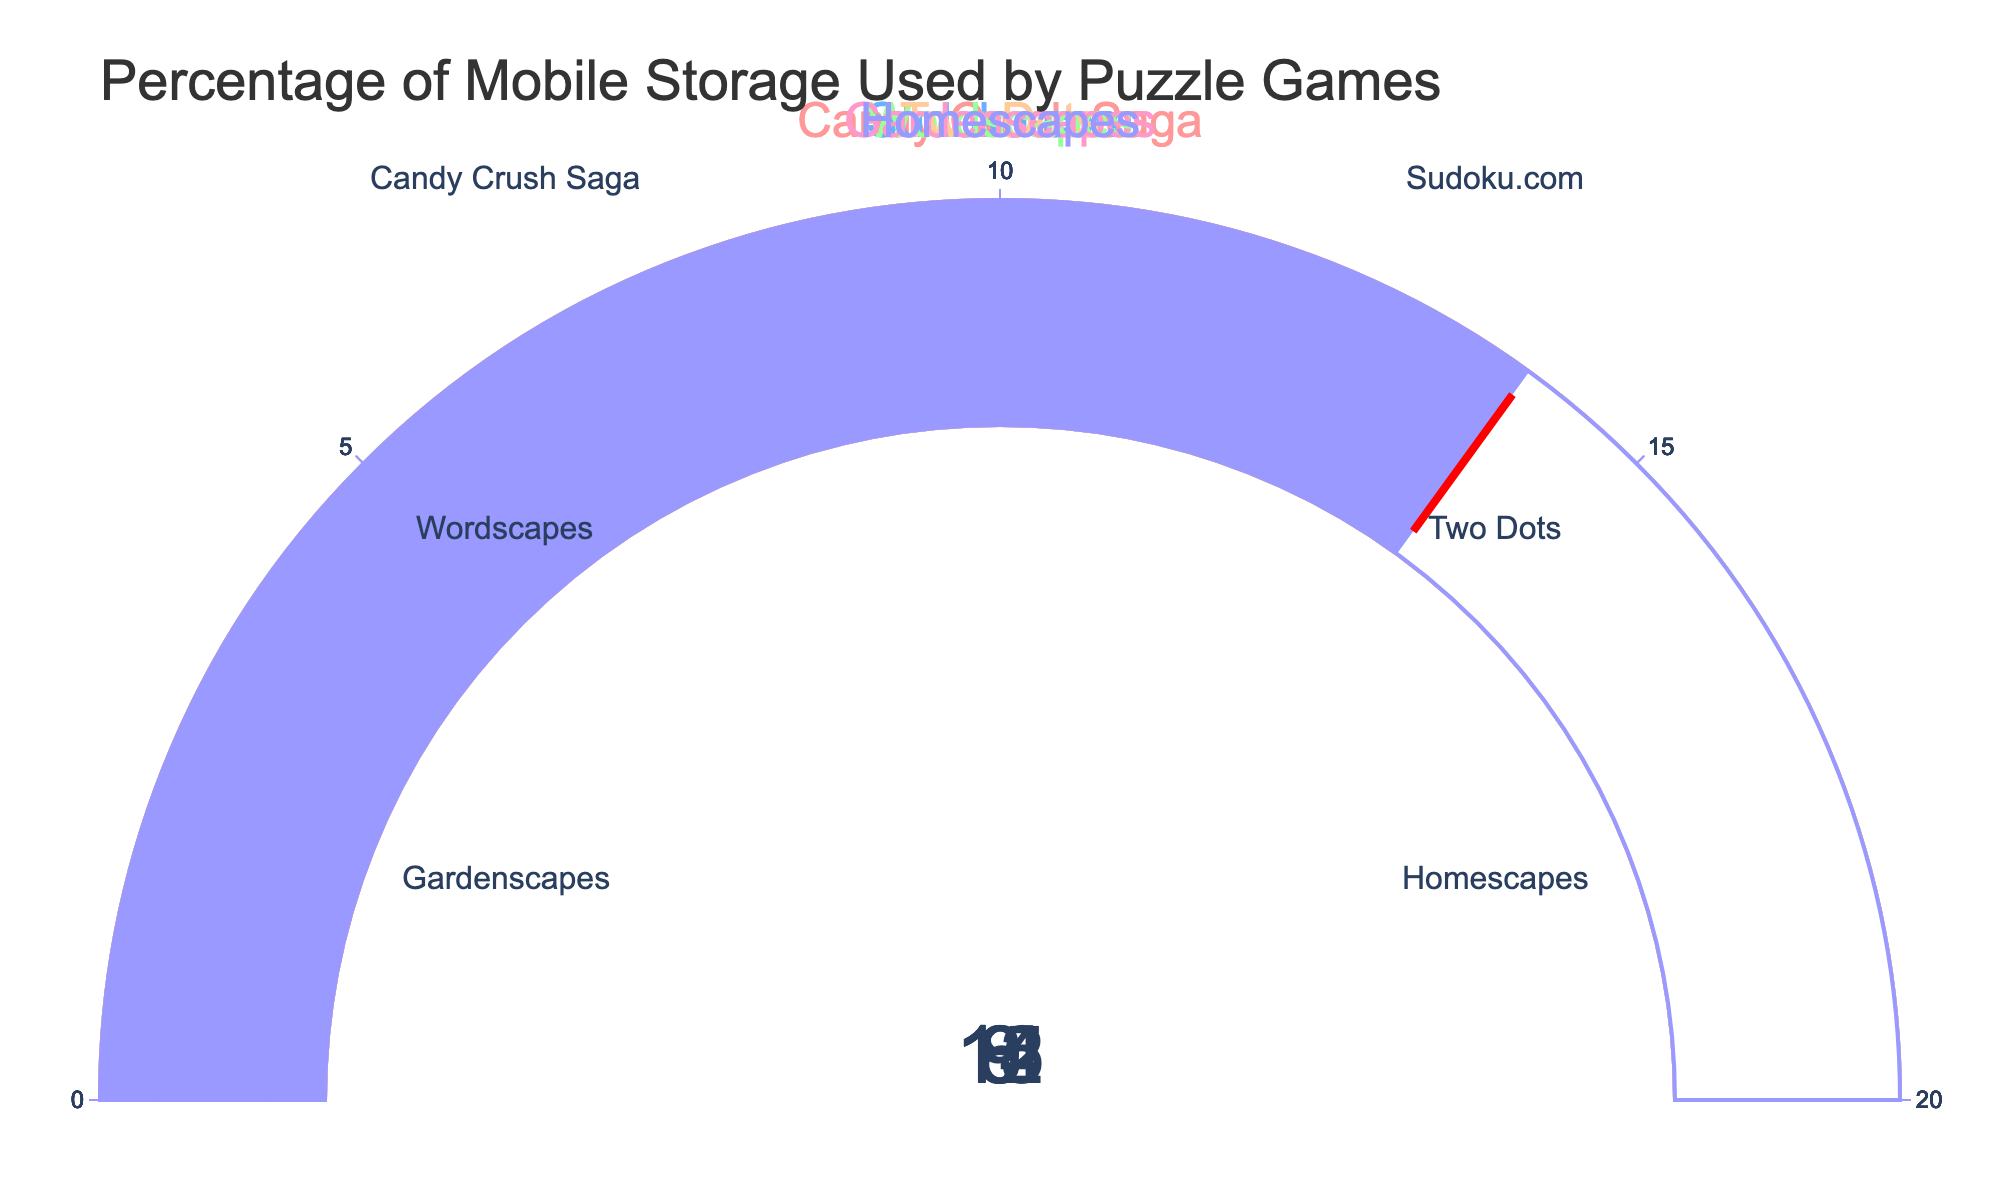What's the title of the figure? The title is typically located at the top of the figure and provides a brief description of the entire plot. In this figure, the title reads "Percentage of Mobile Storage Used by Puzzle Games."
Answer: Percentage of Mobile Storage Used by Puzzle Games How many puzzle games are displayed in the figure? Each gauge chart represents a different puzzle game, and by counting all the gauges, you can determine the number of games. There are six different gauge charts, so there are six games.
Answer: Six Which game uses the highest percentage of mobile storage? By looking at all the gauges, the game with the highest percentage value displayed on its gauge would be the one using the most storage. "Gardenscapes" shows 15%, which is the highest among all games.
Answer: Gardenscapes What's the combined storage percentage used by "Candy Crush Saga" and "Sudoku.com"? To find the combined storage percentage, add the percentages of both games. "Candy Crush Saga" uses 12%, and "Sudoku.com" uses 8%. Adding these gives a total of 12% + 8% = 20%.
Answer: 20% Which game uses less storage, "Wordscapes" or "Two Dots"? Compare the storage percentages shown on the gauges for the two games. "Wordscapes" uses 6%, while "Two Dots" uses 9%. Thus, "Wordscapes" uses less storage.
Answer: Wordscapes What is the average storage percentage used by all the games? To find the average, add all the storage percentages and then divide by the number of games. The percentages are 12%, 8%, 6%, 9%, 15%, and 14%. Adding these values gives a total of 64%. There are 6 games, so the average is 64% / 6 ≈ 10.67%.
Answer: 10.67% What is the difference in storage percentage between "Homescapes" and "Two Dots"? Subtract the storage percentage of "Two Dots" from that of "Homescapes". "Homescapes" uses 14%, and "Two Dots" uses 9%. The difference is 14% - 9% = 5%.
Answer: 5% Which game uses the least amount of storage? The game with the smallest value on its gauge uses the least amount of storage. "Wordscapes" shows 6%, which is the smallest among all games.
Answer: Wordscapes 